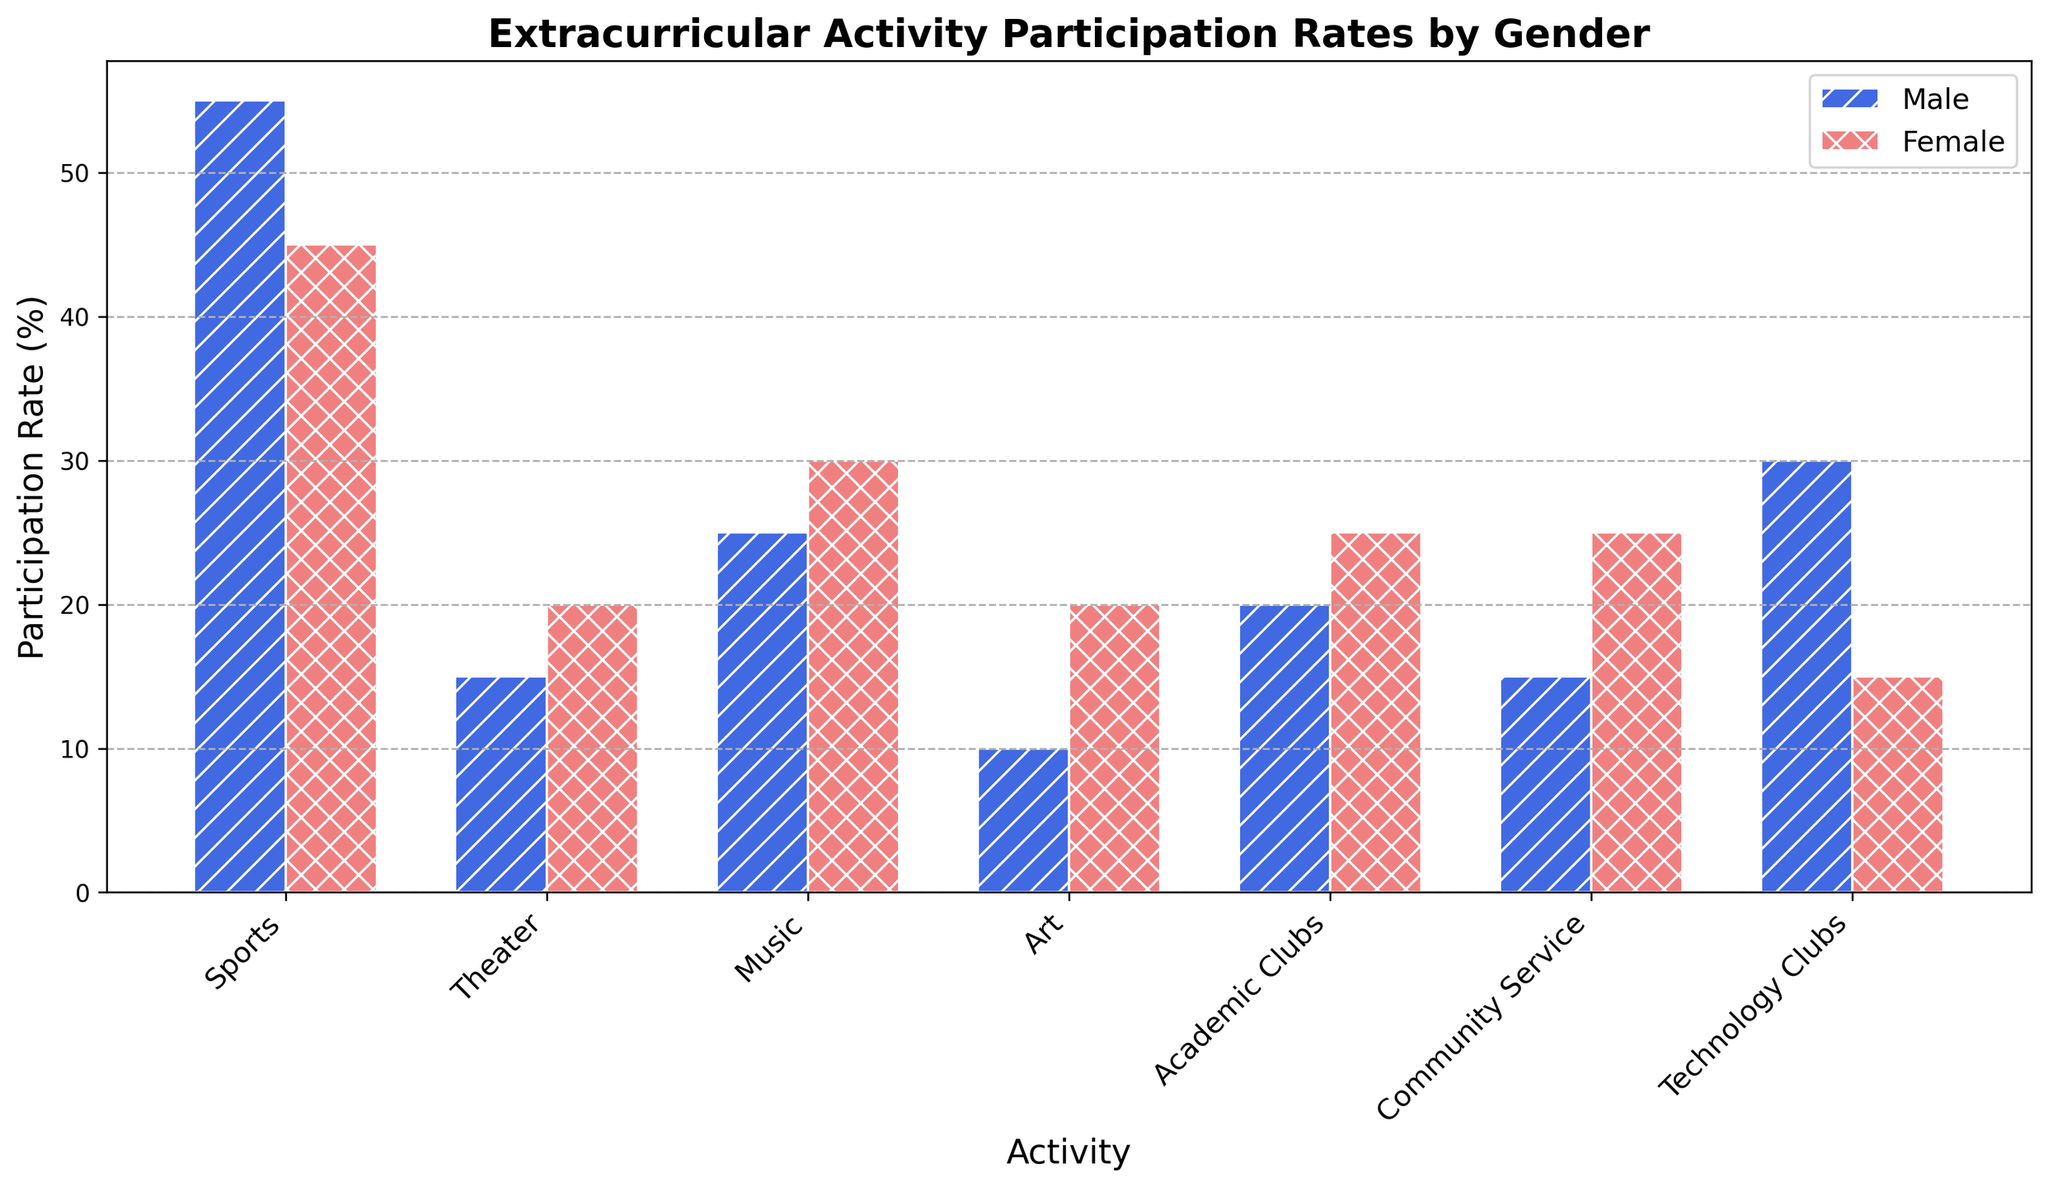Which activity has the highest participation rate for females? From the visual representation, we can observe that Community Service has the tallest bar among activities for females, indicating the highest participation rate.
Answer: Community Service Which activity shows the largest gender difference in participation rates? By examining the differences in bar heights for each activity, we see that Technology Clubs has the largest disparity, with males participating more than females.
Answer: Technology Clubs What is the combined participation rate for males in Music and Art? Look at the heights of the bars for males in Music (25%) and Art (10%), then sum them up. 25% + 10% = 35%
Answer: 35% Which activity do females participate in more than males? Comparing the heights of the bars for males and females for each activity, we find Theater has higher female participation (20%) compared to male participation (15%).
Answer: Theater Among the activities, which ones have equal participation rates for males? We check each pair of bars and find no activities where the heights of the bars for males are the same.
Answer: None What is the average participation rate for females across all activities? Sum the participation rates for females in all activities and divide by the number of activities. The sum is 45% + 20% + 30% + 20% + 25% + 25% + 15% = 180%. Divide by 7: 180% / 7 ≈ 25.7%
Answer: 25.7% Is the participation rate for females in academic clubs greater than in technology clubs? Compare the heights of the bars for females in Academic Clubs (25%) with Technology Clubs (15%). 25% > 15%, so the answer is yes.
Answer: Yes Which activity has the lowest participation rate for males? From visual observation, Art has the shortest bar among the activities for males, showing the lowest participation rate at 10%.
Answer: Art What is the total participation rate for both genders in Sports? Add the participation rates for males (55%) and females (45%) in Sports. 55% + 45% = 100%
Answer: 100% Between Theater and Community Service, which activity has a balanced participation rate between genders? Compare the difference in bar heights for males and females in both activities. Theater has a difference of 5% (20% - 15%), while Community Service has a difference of 10% (25% - 15%). Thus, Theater is more balanced.
Answer: Theater 